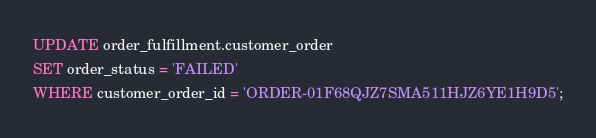Convert code to text. <code><loc_0><loc_0><loc_500><loc_500><_SQL_>UPDATE order_fulfillment.customer_order
SET order_status = 'FAILED'
WHERE customer_order_id = 'ORDER-01F68QJZ7SMA511HJZ6YE1H9D5';
</code> 